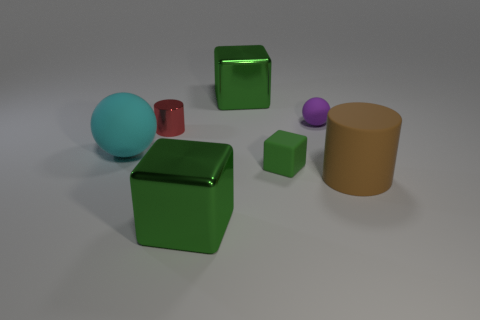There is a red cylinder; is its size the same as the green shiny cube in front of the large brown matte object? The size of the red cylinder is not the same as that of the green shiny cube. The cylinder has a round shape with continuous curved sides and a circular base, while the cube has a box-like structure with six square faces. The cube also appears slightly larger and more prominent when compared to the cylinder. 